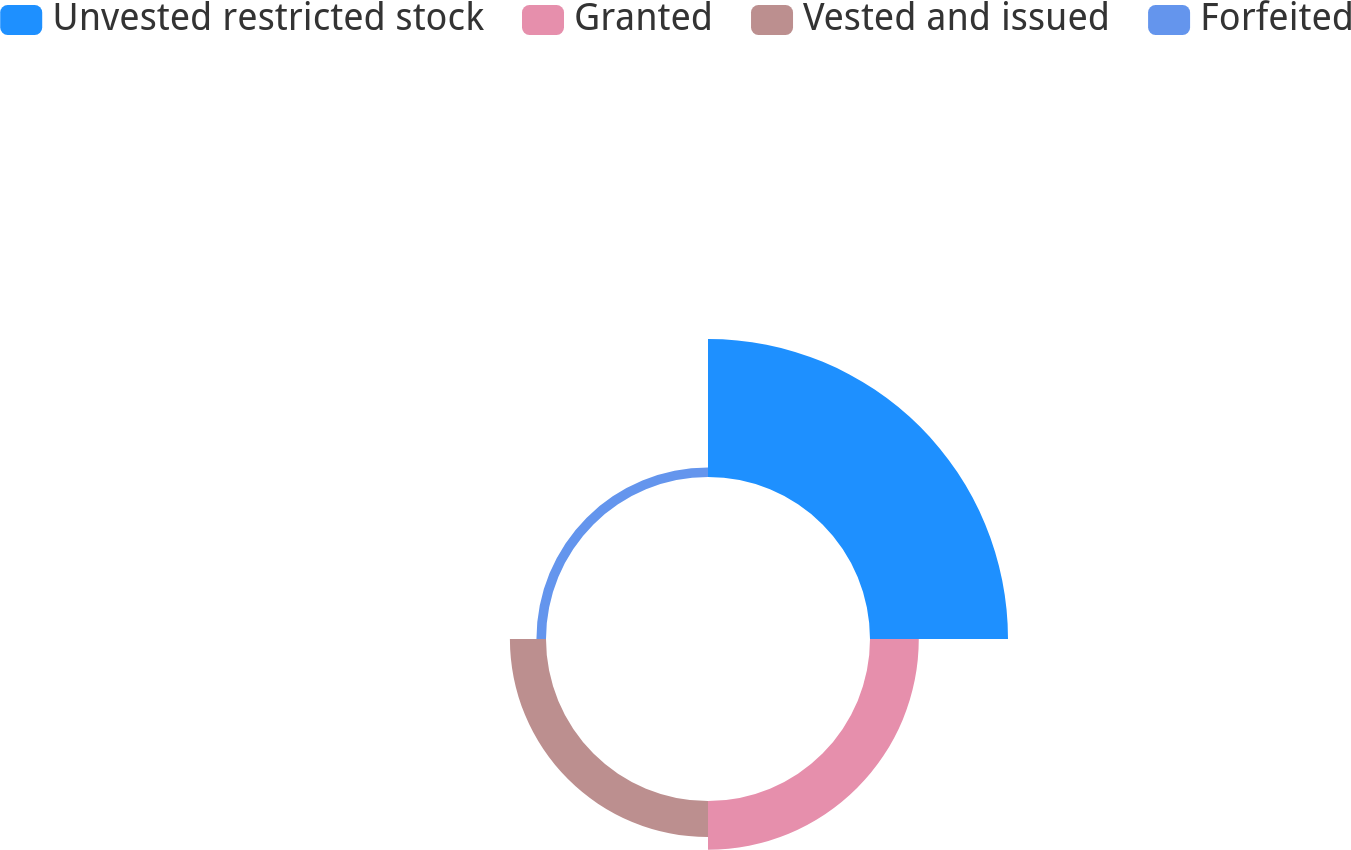Convert chart to OTSL. <chart><loc_0><loc_0><loc_500><loc_500><pie_chart><fcel>Unvested restricted stock<fcel>Granted<fcel>Vested and issued<fcel>Forfeited<nl><fcel>59.37%<fcel>20.99%<fcel>15.53%<fcel>4.11%<nl></chart> 